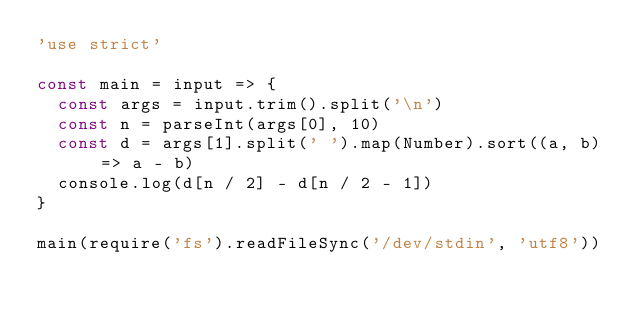<code> <loc_0><loc_0><loc_500><loc_500><_JavaScript_>'use strict'

const main = input => {
	const args = input.trim().split('\n')
	const n = parseInt(args[0], 10)
	const d = args[1].split(' ').map(Number).sort((a, b) => a - b)
	console.log(d[n / 2] - d[n / 2 - 1])
}

main(require('fs').readFileSync('/dev/stdin', 'utf8'))
</code> 